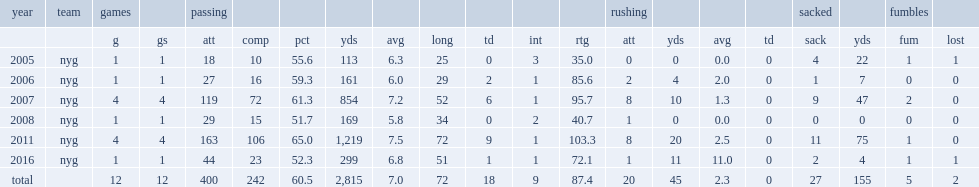How many passing touchdowns did manning complete in 2008? 0.0. 